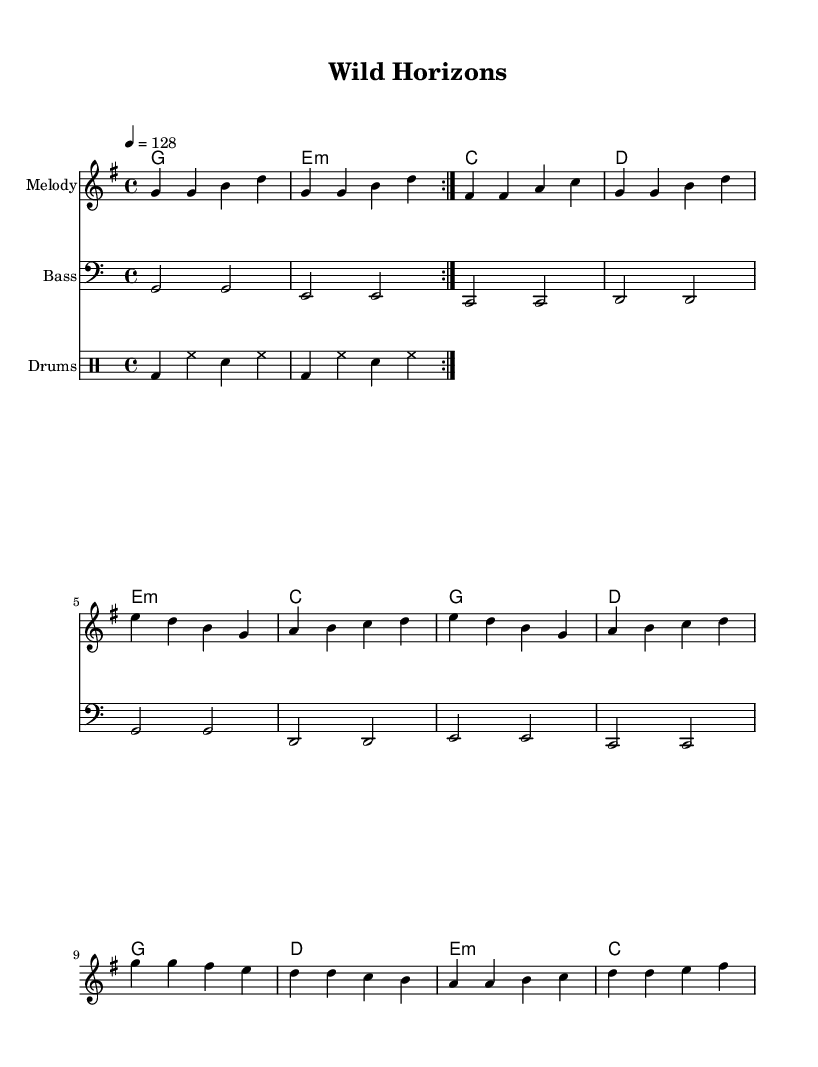What is the key signature of this music? The key signature is G major, which has one sharp (F#). This is easily visible at the beginning of the sheet music where the key signature is indicated.
Answer: G major What is the time signature of the piece? The time signature is 4/4, meaning there are four beats in each measure and a quarter note counts as one beat. This is also indicated at the beginning of the score.
Answer: 4/4 What is the tempo marking for this piece? The tempo marking is 128 beats per minute, which is shown as "4 = 128" in the tempo directive. This indicates how fast the piece should be played.
Answer: 128 How many measures are there in the chorus section? The chorus contains four measures, as indicated by the notation and the layout of the melody section. You can count the measures labeled in the sheet music for the chorus specifically.
Answer: 4 What type of music is this? The piece is categorized as electronic dance music, which is often characterized by upbeat tempos, repetitive beats, and synthesized sounds. This can be inferred from the title "Wild Horizons" and the energetic structure of the music.
Answer: Electronic dance music What instruments are featured in this score? The score features a Melody part, a Bass part, and a Drums part, as indicated by separate staffs for each instrument in the score layout.
Answer: Melody, Bass, Drums Which chord appears most frequently in the harmony section? The G major chord appears most frequently, occurring four times in the harmony part throughout the piece. This can be identified by counting each time the G chord is specified in the chord progression.
Answer: G major 